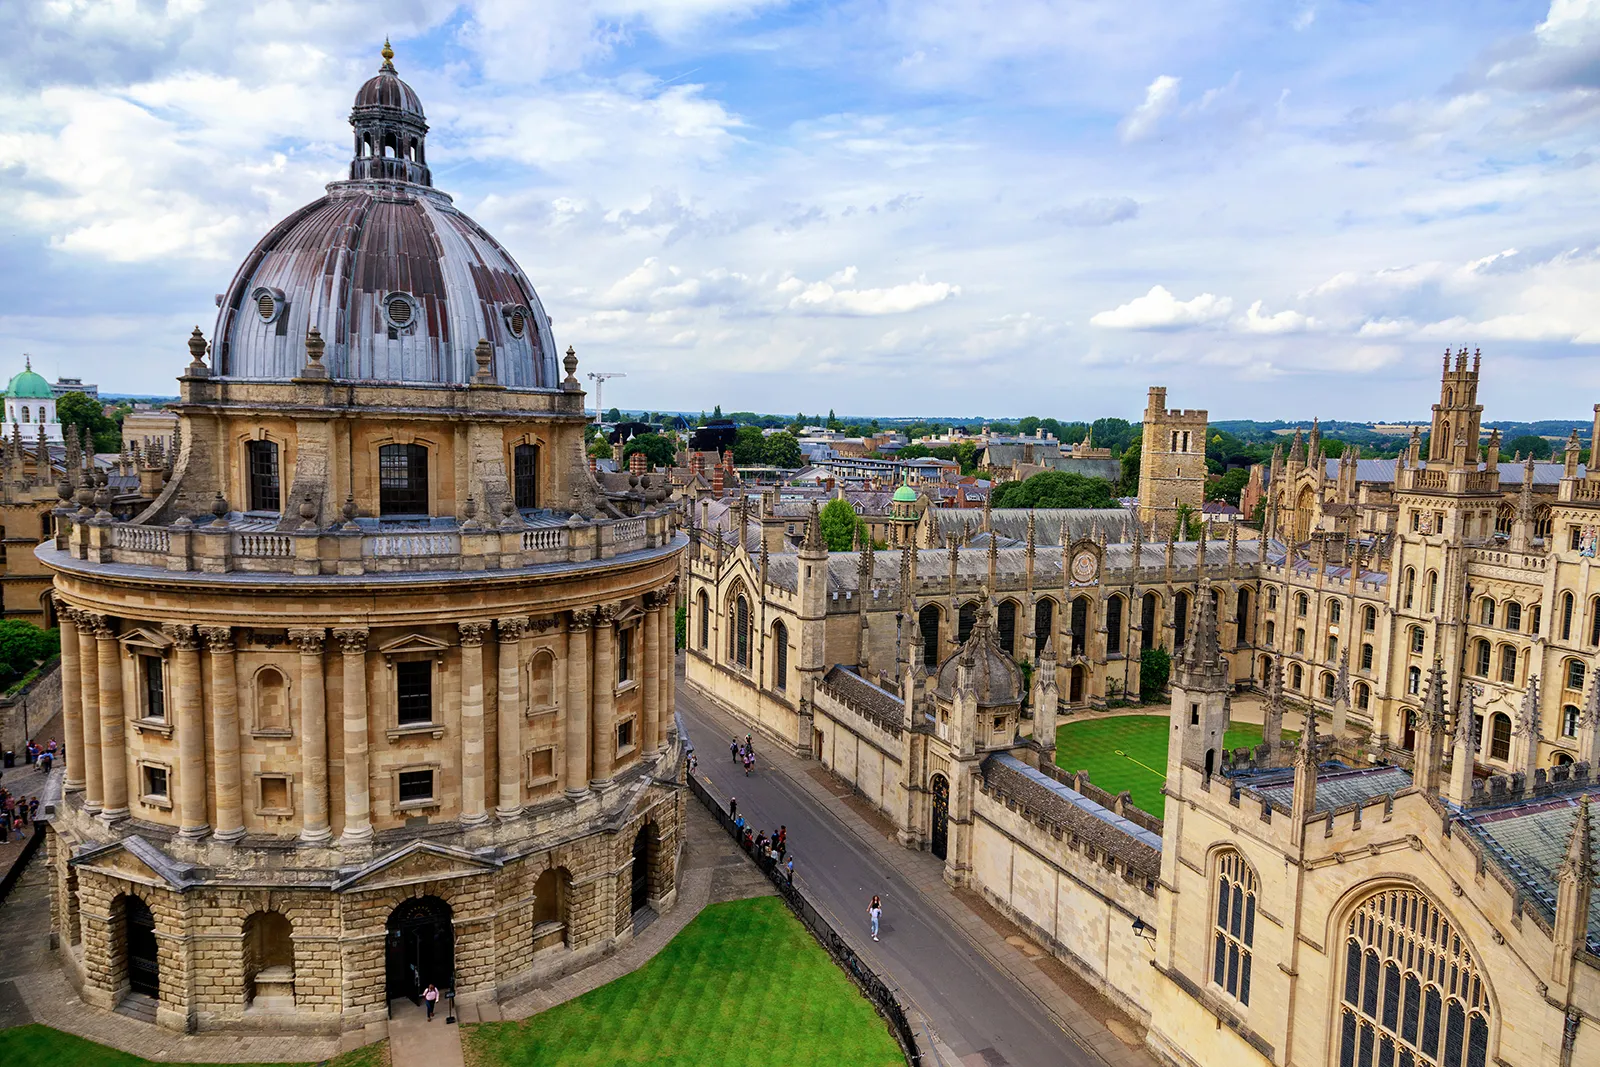What do you think is going on in this snapshot? This snapshot showcases the iconic Radcliffe Camera, a renowned library that is part of Oxford University in England. This magnificent circular building, with its striking dome, stands as a testament to the exquisite architectural expertise of the 18th century. The light-colored stone structure, adorned with numerous windows, contributes to its grandeur.

The high-angle view in the photograph offers a comprehensive perspective of the Radcliffe Camera and its surrounding area. The building is set amidst lush green lawns and mature trees, creating a serene academic ambiance. In the backdrop, other notable structures of Oxford University, such as All Souls College and the University Church of St Mary the Virgin, are also visible, reflecting the university's rich history and academic tradition.

The clear blue sky with a few clouds above adds to the tranquility of the scene, encapsulating the essence of Oxford University, one of the oldest and most prestigious educational institutions in the world. 